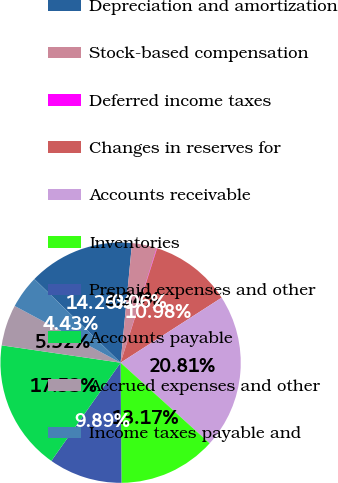Convert chart. <chart><loc_0><loc_0><loc_500><loc_500><pie_chart><fcel>Depreciation and amortization<fcel>Stock-based compensation<fcel>Deferred income taxes<fcel>Changes in reserves for<fcel>Accounts receivable<fcel>Inventories<fcel>Prepaid expenses and other<fcel>Accounts payable<fcel>Accrued expenses and other<fcel>Income taxes payable and<nl><fcel>14.26%<fcel>3.34%<fcel>0.06%<fcel>10.98%<fcel>20.81%<fcel>13.17%<fcel>9.89%<fcel>17.53%<fcel>5.52%<fcel>4.43%<nl></chart> 